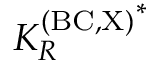Convert formula to latex. <formula><loc_0><loc_0><loc_500><loc_500>{ K _ { R } ^ { ( B C , X ) } } ^ { * }</formula> 